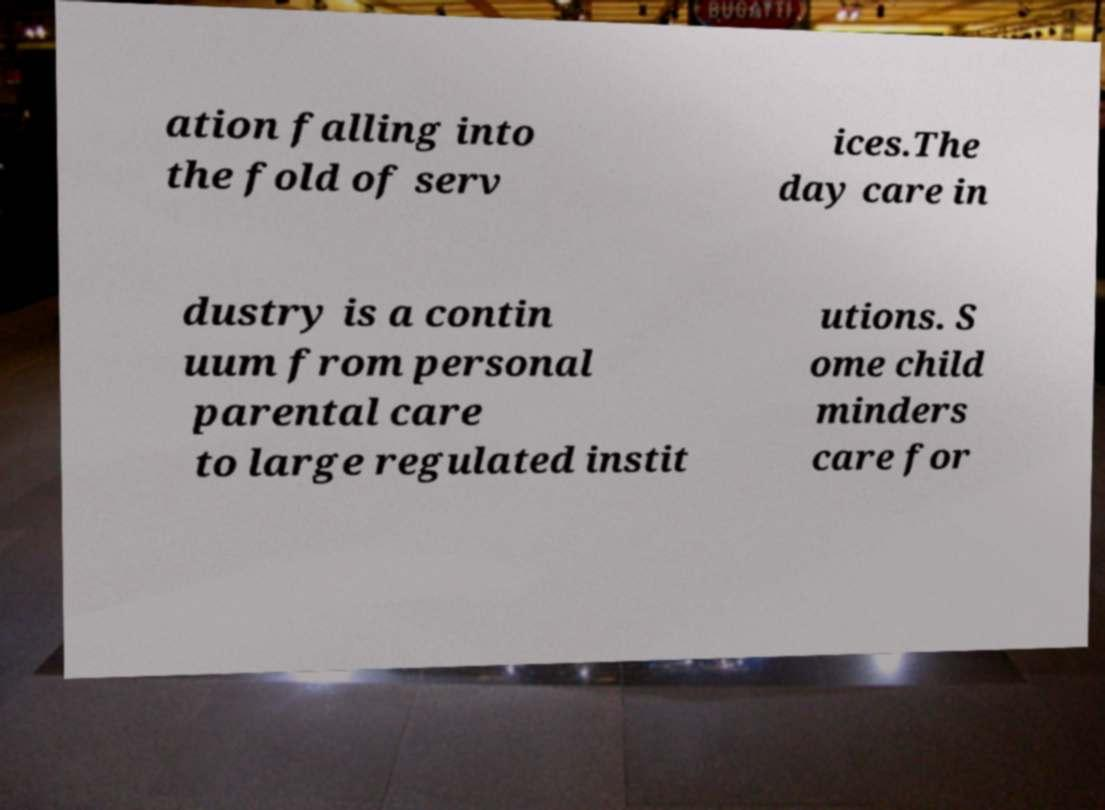Could you assist in decoding the text presented in this image and type it out clearly? ation falling into the fold of serv ices.The day care in dustry is a contin uum from personal parental care to large regulated instit utions. S ome child minders care for 